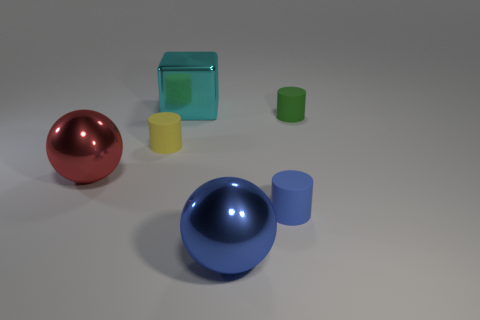There is a small object to the left of the large cyan metallic block; what material is it?
Offer a terse response. Rubber. Does the shiny block have the same size as the blue metallic sphere?
Offer a terse response. Yes. Is the number of shiny things that are in front of the large blue sphere greater than the number of gray matte cylinders?
Offer a terse response. No. The ball that is made of the same material as the red object is what size?
Provide a short and direct response. Large. Are there any tiny yellow rubber things in front of the large shiny cube?
Give a very brief answer. Yes. Is the shape of the yellow matte object the same as the blue metal thing?
Your answer should be very brief. No. There is a metallic thing in front of the big shiny sphere that is left of the shiny object behind the green cylinder; what is its size?
Ensure brevity in your answer.  Large. What is the material of the large blue object?
Offer a terse response. Metal. There is a red metallic object; does it have the same shape as the big thing that is behind the green matte object?
Your response must be concise. No. The blue object behind the large metallic ball in front of the small rubber cylinder that is in front of the yellow matte cylinder is made of what material?
Offer a terse response. Rubber. 